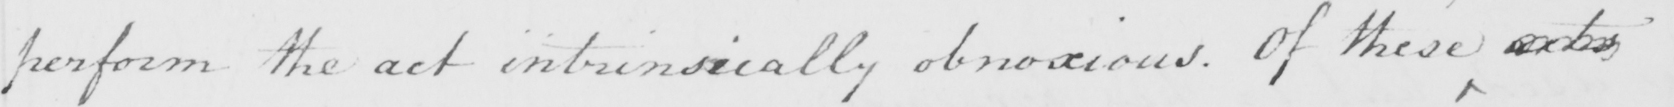Can you tell me what this handwritten text says? perform the act intrinsically obnoxious. Of these acts 